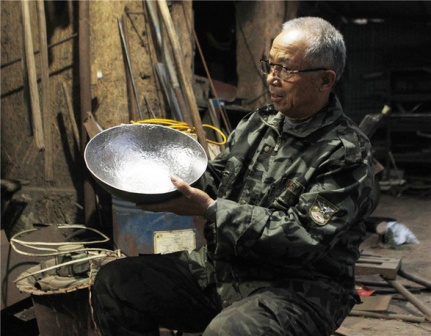Describe a day in the life of the man in the workshop. A typical day for the man starts early, as he enters his workshop with a focused mind and a heart full of passion. He begins by organizing the tools, ensuring everything is in its rightful place. His morning is spent sketching designs and planning for the day's project. By mid-morning, the sound of sawing and hammering fills the air as he becomes engrossed in creating or repairing an item.

He takes a brief lunch break, usually spent reflecting on his work and perhaps making notes on how to improve his techniques. The afternoon is dedicated to the finer details—sanding edges, adding intricate carvings, or welding parts together. As evening approaches, he takes a step back to review his work, cleaning up his space and preparing for the next day. The satisfaction of seeing a nearly finished piece provides him with a sense of accomplishment and motivation to continue his craft. Is there any significance to the blue barrel in the background? The blue barrel in the background could have a variety of significances. It might be used for storing raw materials or collecting scraps and waste from projects. Its noticeable color amidst the muted tones of the workshop could symbolize the presence of an essential but often overlooked element of the creative process. It reminds us that even in the most practical spaces, there is always a splash of unexpected color and utility, contributing to the overall functionality and character of the workspace. 